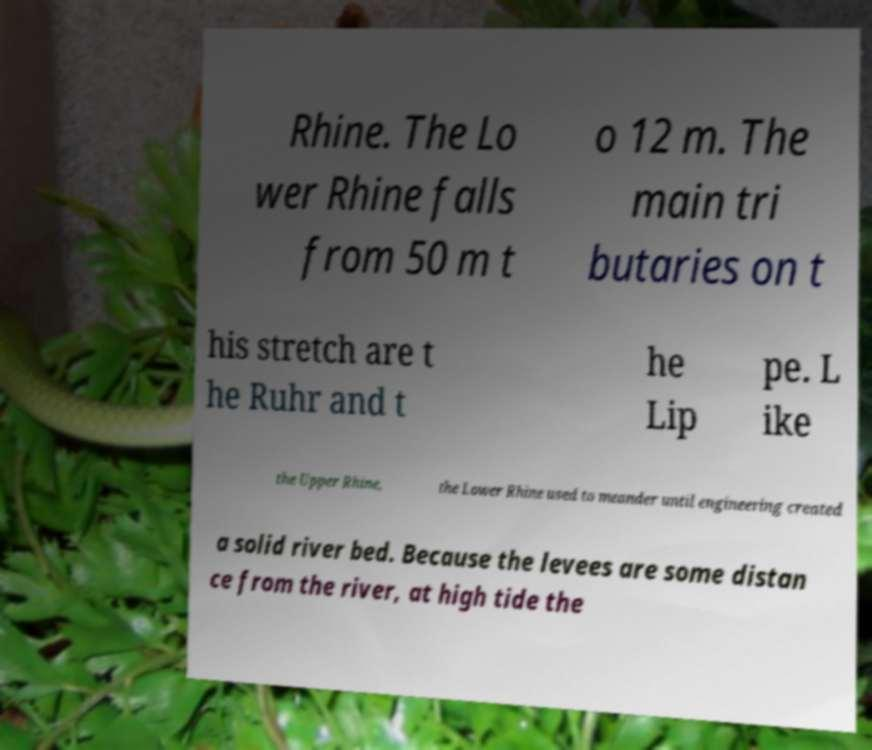For documentation purposes, I need the text within this image transcribed. Could you provide that? Rhine. The Lo wer Rhine falls from 50 m t o 12 m. The main tri butaries on t his stretch are t he Ruhr and t he Lip pe. L ike the Upper Rhine, the Lower Rhine used to meander until engineering created a solid river bed. Because the levees are some distan ce from the river, at high tide the 